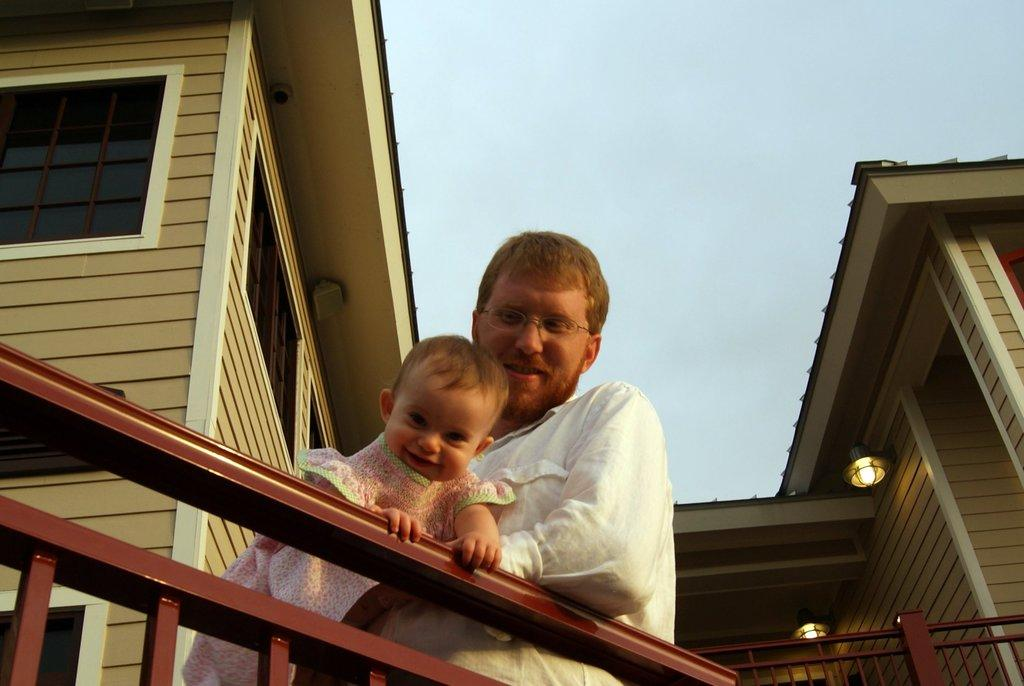What is the man in the image holding? The man is holding a baby in the image. What can be seen in the background of the image? There is a building and the sky visible in the background of the image. What type of structure is present in the image? There is a railing in the image. What else can be seen in the image besides the man and the baby? There are lights in the image. What type of suit is the baby wearing in the image? There is no suit present in the image; the baby is not wearing any clothing. Are there any dinosaurs visible in the image? No, there are no dinosaurs present in the image. 